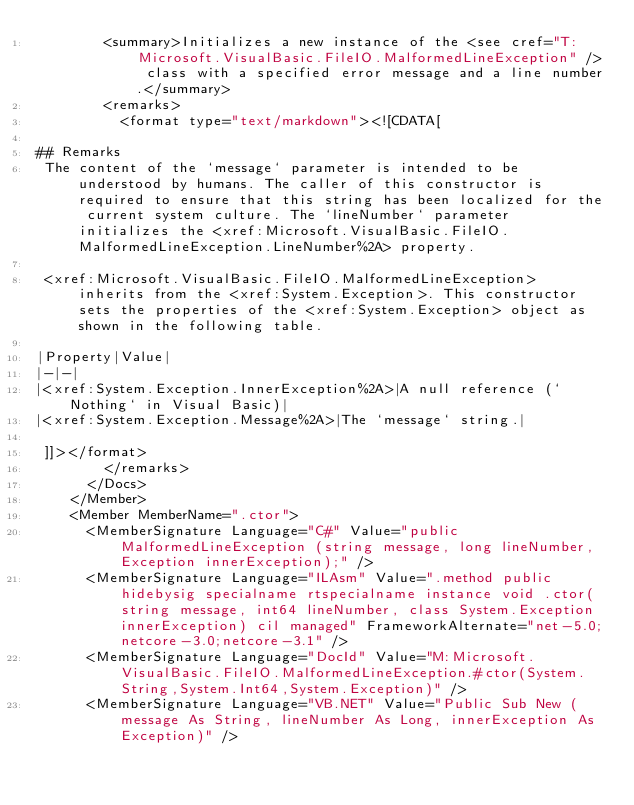<code> <loc_0><loc_0><loc_500><loc_500><_XML_>        <summary>Initializes a new instance of the <see cref="T:Microsoft.VisualBasic.FileIO.MalformedLineException" /> class with a specified error message and a line number.</summary>
        <remarks>
          <format type="text/markdown"><![CDATA[  
  
## Remarks  
 The content of the `message` parameter is intended to be understood by humans. The caller of this constructor is required to ensure that this string has been localized for the current system culture. The `lineNumber` parameter initializes the <xref:Microsoft.VisualBasic.FileIO.MalformedLineException.LineNumber%2A> property.  
  
 <xref:Microsoft.VisualBasic.FileIO.MalformedLineException> inherits from the <xref:System.Exception>. This constructor sets the properties of the <xref:System.Exception> object as shown in the following table.  
  
|Property|Value|  
|-|-|  
|<xref:System.Exception.InnerException%2A>|A null reference (`Nothing` in Visual Basic)|  
|<xref:System.Exception.Message%2A>|The `message` string.|  
  
 ]]></format>
        </remarks>
      </Docs>
    </Member>
    <Member MemberName=".ctor">
      <MemberSignature Language="C#" Value="public MalformedLineException (string message, long lineNumber, Exception innerException);" />
      <MemberSignature Language="ILAsm" Value=".method public hidebysig specialname rtspecialname instance void .ctor(string message, int64 lineNumber, class System.Exception innerException) cil managed" FrameworkAlternate="net-5.0;netcore-3.0;netcore-3.1" />
      <MemberSignature Language="DocId" Value="M:Microsoft.VisualBasic.FileIO.MalformedLineException.#ctor(System.String,System.Int64,System.Exception)" />
      <MemberSignature Language="VB.NET" Value="Public Sub New (message As String, lineNumber As Long, innerException As Exception)" /></code> 